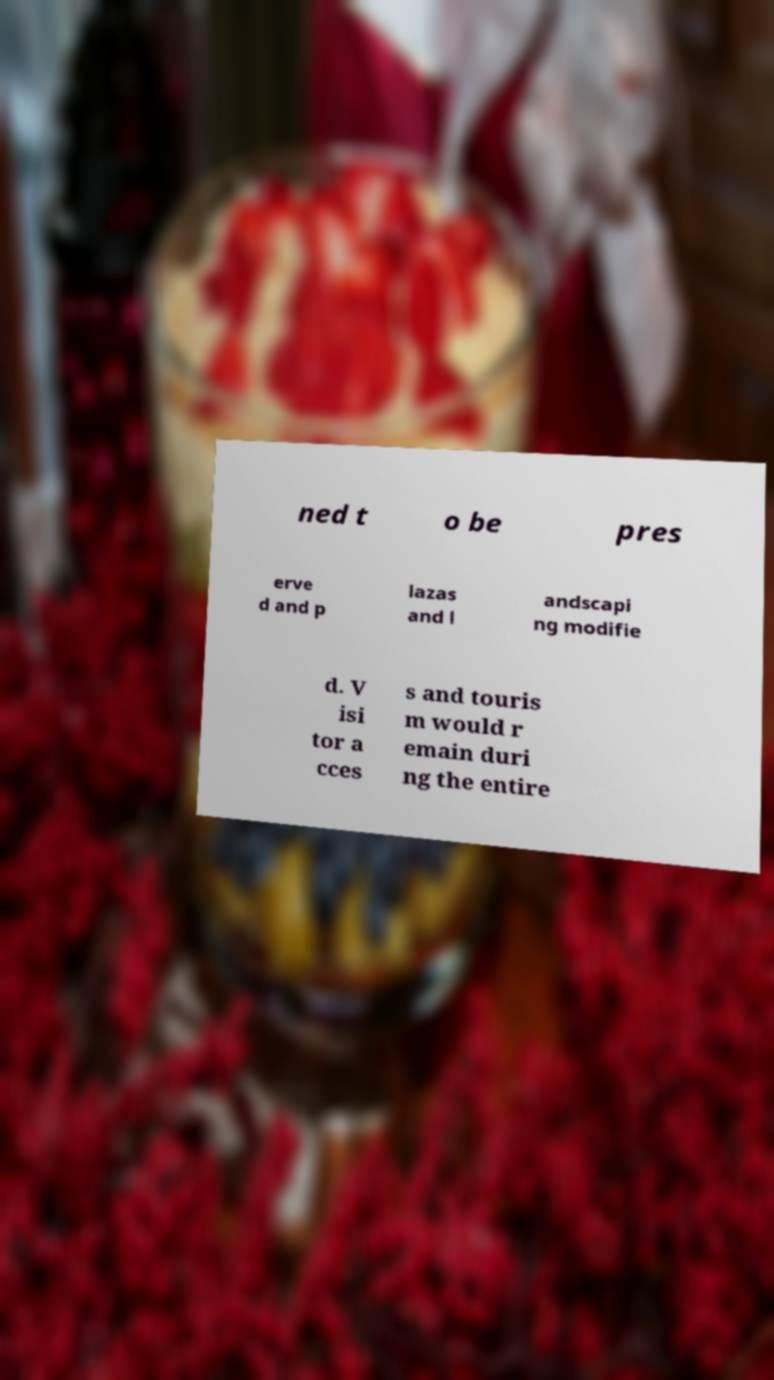Could you assist in decoding the text presented in this image and type it out clearly? ned t o be pres erve d and p lazas and l andscapi ng modifie d. V isi tor a cces s and touris m would r emain duri ng the entire 